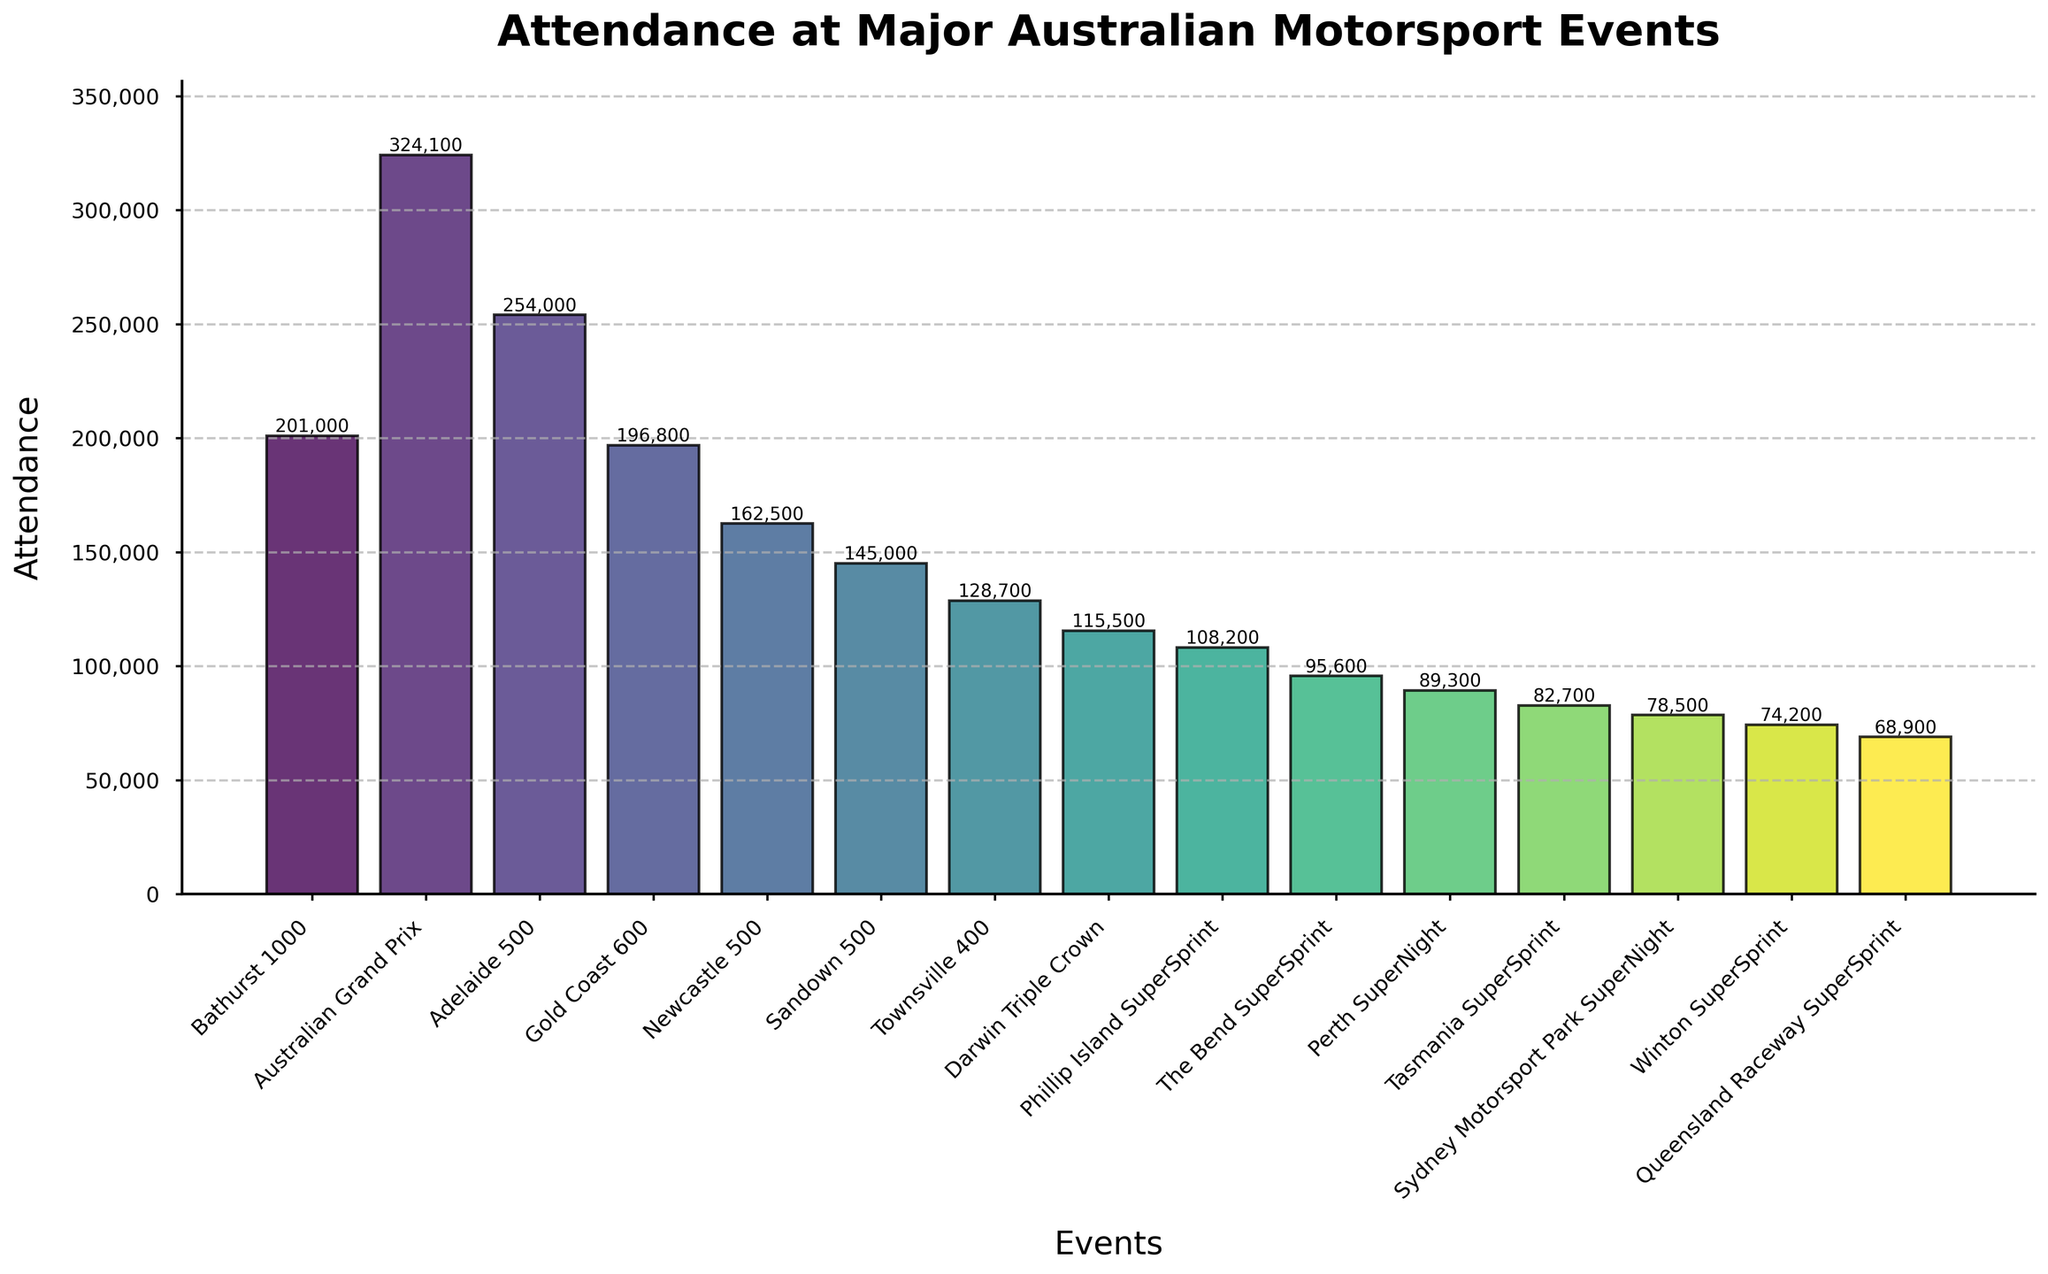Which event has the highest attendance? To find the event with the highest attendance, look for the tallest bar in the chart. The Australian Grand Prix has the tallest bar indicating the highest attendance.
Answer: Australian Grand Prix Which event has the lowest attendance? Identify the shortest bar in the chart, which represents the event with the lowest attendance. Queensland Raceway SuperSprint has the shortest bar.
Answer: Queensland Raceway SuperSprint What is the difference in attendance between the Bathurst 1000 and the Gold Coast 600? Locate the heights of the Bathurst 1000 and Gold Coast 600 bars. Subtract the Gold Coast 600 attendance (196,800) from Bathurst 1000 attendance (201,000).
Answer: 4,200 What is the average attendance of the top 3 events? Identify the top 3 events by the height of their bars: Australian Grand Prix (324,100), Adelaide 500 (254,000), and Bathurst 1000 (201,000). Calculate the average by summing them up and dividing by 3: (324,100 + 254,000 + 201,000) / 3 = 779,100 / 3.
Answer: 259,700 Which is greater, the total attendance of the lowest 5 events or the attendance of the Adelaide 500 alone? Sum the attendances of the five lowest events: The Bend SuperSprint (95,600), Perth SuperNight (89,300), Tasmania SuperSprint (82,700), Sydney Motorsport Park SuperNight (78,500), and Winton SuperSprint (74,200). Sum = 420,300. Compare to the attendance of Adelaide 500 (254,000).
Answer: The lowest 5 What is the total attendance for all events combined? Sum the attendances of all events listed: 201,000 + 324,100 + 254,000 + 196,800 + 162,500 + 145,000 + 128,700 + 115,500 + 108,200 + 95,600 + 89,300 + 82,700 + 78,500 + 74,200 + 68,900.
Answer: 2,124,000 What percentage of total attendance is accounted for by the Australian Grand Prix? First, find the total attendance (2,124,000). Then, divide the Australian Grand Prix attendance (324,100) by the total and multiply by 100. (324,100 / 2,124,000) * 100.
Answer: 15.26% Does the Sandown 500 have a higher attendance than the Townsville 400? Compare the heights of the bars for Sandown 500 (145,000) and Townsville 400 (128,700). Since 145,000 is greater than 128,700, Sandown 500 has a higher attendance.
Answer: Yes Which event has an attendance closest to 100,000? Locate the bar with attendance near 100,000. The closest bar is the Phillip Island SuperSprint with an attendance of 108,200.
Answer: Phillip Island SuperSprint How does the attendance of the Sydney Motorsport Park SuperNight compare to the next lowest event? Identify the attendance of the Sydney Motorsport Park SuperNight (78,500) and the Winton SuperSprint (74,200). Since 78,500 is greater than 74,200, Sydney Motorsport Park SuperNight has higher attendance.
Answer: Higher 